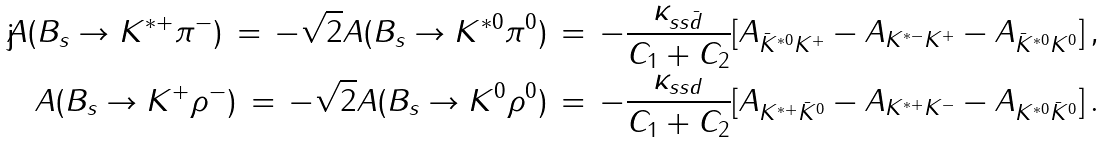<formula> <loc_0><loc_0><loc_500><loc_500>A ( B _ { s } \to K ^ { * + } \pi ^ { - } ) \, = \, - \sqrt { 2 } A ( B _ { s } \to K ^ { * 0 } \pi ^ { 0 } ) \, = \, - \frac { \kappa _ { s s \bar { d } } } { C _ { 1 } + C _ { 2 } } [ A _ { \bar { K } ^ { * 0 } K ^ { + } } - A _ { K ^ { * - } K ^ { + } } - A _ { \bar { K } ^ { * 0 } K ^ { 0 } } ] \, , \\ A ( B _ { s } \to K ^ { + } \rho ^ { - } ) \, = \, - \sqrt { 2 } A ( B _ { s } \to K ^ { 0 } \rho ^ { 0 } ) \, = \, - \frac { \kappa _ { s s d } } { C _ { 1 } + C _ { 2 } } [ A _ { K ^ { * + } \bar { K } ^ { 0 } } - A _ { K ^ { * + } K ^ { - } } - A _ { K ^ { * 0 } \bar { K } ^ { 0 } } ] \, .</formula> 